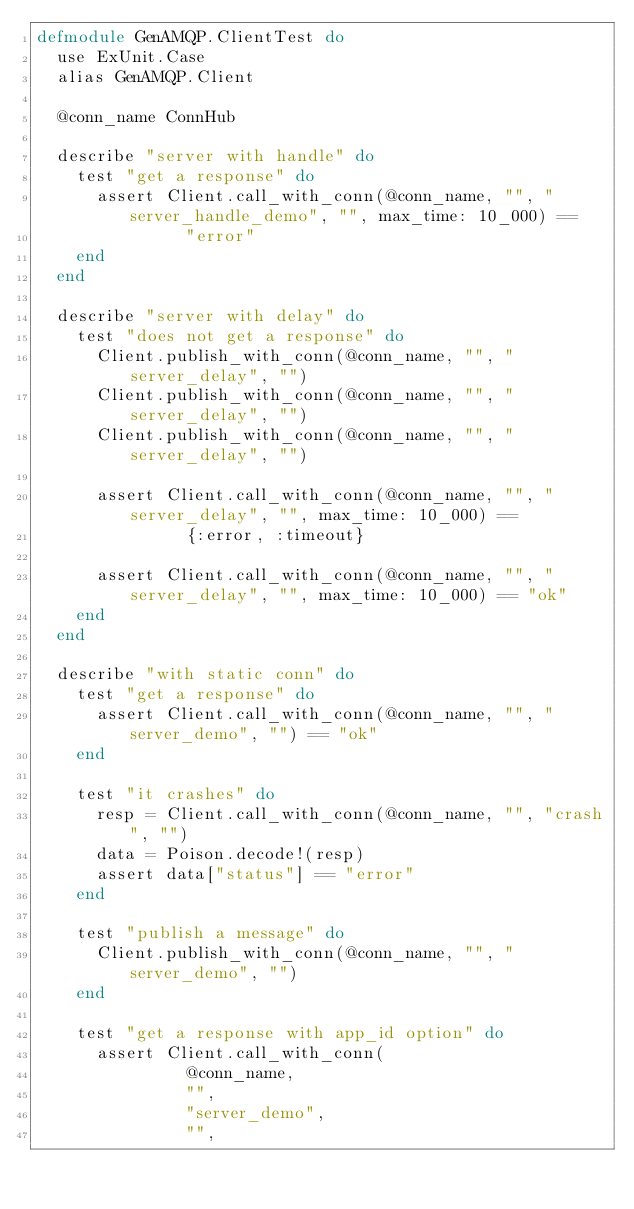<code> <loc_0><loc_0><loc_500><loc_500><_Elixir_>defmodule GenAMQP.ClientTest do
  use ExUnit.Case
  alias GenAMQP.Client

  @conn_name ConnHub

  describe "server with handle" do
    test "get a response" do
      assert Client.call_with_conn(@conn_name, "", "server_handle_demo", "", max_time: 10_000) ==
               "error"
    end
  end

  describe "server with delay" do
    test "does not get a response" do
      Client.publish_with_conn(@conn_name, "", "server_delay", "")
      Client.publish_with_conn(@conn_name, "", "server_delay", "")
      Client.publish_with_conn(@conn_name, "", "server_delay", "")

      assert Client.call_with_conn(@conn_name, "", "server_delay", "", max_time: 10_000) ==
               {:error, :timeout}

      assert Client.call_with_conn(@conn_name, "", "server_delay", "", max_time: 10_000) == "ok"
    end
  end

  describe "with static conn" do
    test "get a response" do
      assert Client.call_with_conn(@conn_name, "", "server_demo", "") == "ok"
    end

    test "it crashes" do
      resp = Client.call_with_conn(@conn_name, "", "crash", "")
      data = Poison.decode!(resp)
      assert data["status"] == "error"
    end

    test "publish a message" do
      Client.publish_with_conn(@conn_name, "", "server_demo", "")
    end

    test "get a response with app_id option" do
      assert Client.call_with_conn(
               @conn_name,
               "",
               "server_demo",
               "",</code> 